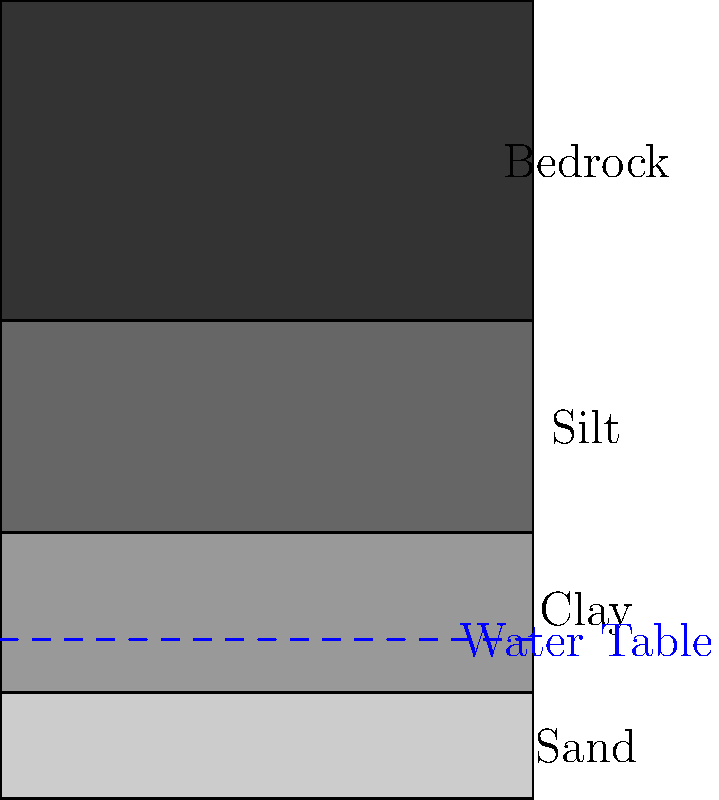Based on the soil profile illustration for an offshore wind turbine foundation, what type of foundation would you recommend, and at what approximate depth should it be installed to ensure stability and minimize environmental impact? To determine the appropriate foundation type and depth for an offshore wind turbine, we need to analyze the soil profile:

1. The soil profile shows four distinct layers:
   - Sand (0-20m)
   - Clay (20-50m)
   - Silt (50-90m)
   - Bedrock (90-150m)

2. The water table is located at 30m depth, which means the upper layers are submerged.

3. For offshore wind turbines, common foundation types include monopiles, jacket foundations, and gravity-based foundations.

4. Considering the soil profile:
   - The sand layer is relatively thin and submerged, offering limited support.
   - The clay layer is also submerged and may have lower bearing capacity.
   - The silt layer is thicker but still not ideal for foundation support.
   - The bedrock layer offers the best stability and bearing capacity.

5. Given the depth of the bedrock (90m), a jacket foundation would be most suitable:
   - It can reach greater depths than monopiles.
   - It provides better stability in varied soil conditions.
   - It has less environmental impact compared to gravity-based foundations.

6. The foundation should be anchored into the bedrock layer to ensure maximum stability:
   - Recommended depth: Approximately 100-110m.
   - This depth allows the foundation to be securely embedded in the bedrock while minimizing excessive drilling.

7. The jacket foundation at this depth will:
   - Bypass the weaker upper soil layers.
   - Resist lateral loads from wind and waves effectively.
   - Minimize scour concerns in the upper sand layer.
   - Provide long-term stability for the wind turbine.
Answer: Jacket foundation at 100-110m depth, anchored in bedrock. 